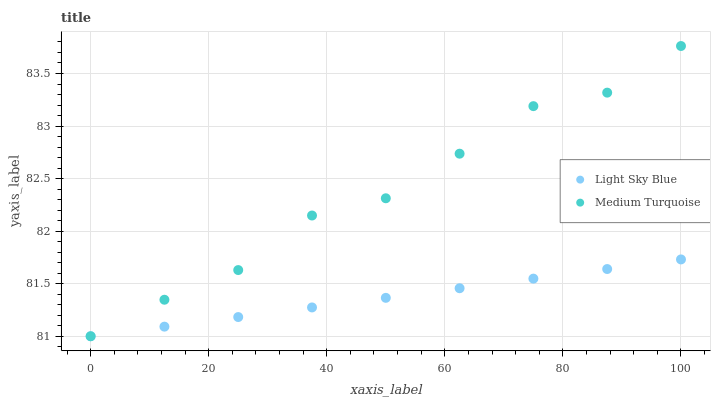Does Light Sky Blue have the minimum area under the curve?
Answer yes or no. Yes. Does Medium Turquoise have the maximum area under the curve?
Answer yes or no. Yes. Does Medium Turquoise have the minimum area under the curve?
Answer yes or no. No. Is Light Sky Blue the smoothest?
Answer yes or no. Yes. Is Medium Turquoise the roughest?
Answer yes or no. Yes. Is Medium Turquoise the smoothest?
Answer yes or no. No. Does Light Sky Blue have the lowest value?
Answer yes or no. Yes. Does Medium Turquoise have the highest value?
Answer yes or no. Yes. Does Medium Turquoise intersect Light Sky Blue?
Answer yes or no. Yes. Is Medium Turquoise less than Light Sky Blue?
Answer yes or no. No. Is Medium Turquoise greater than Light Sky Blue?
Answer yes or no. No. 